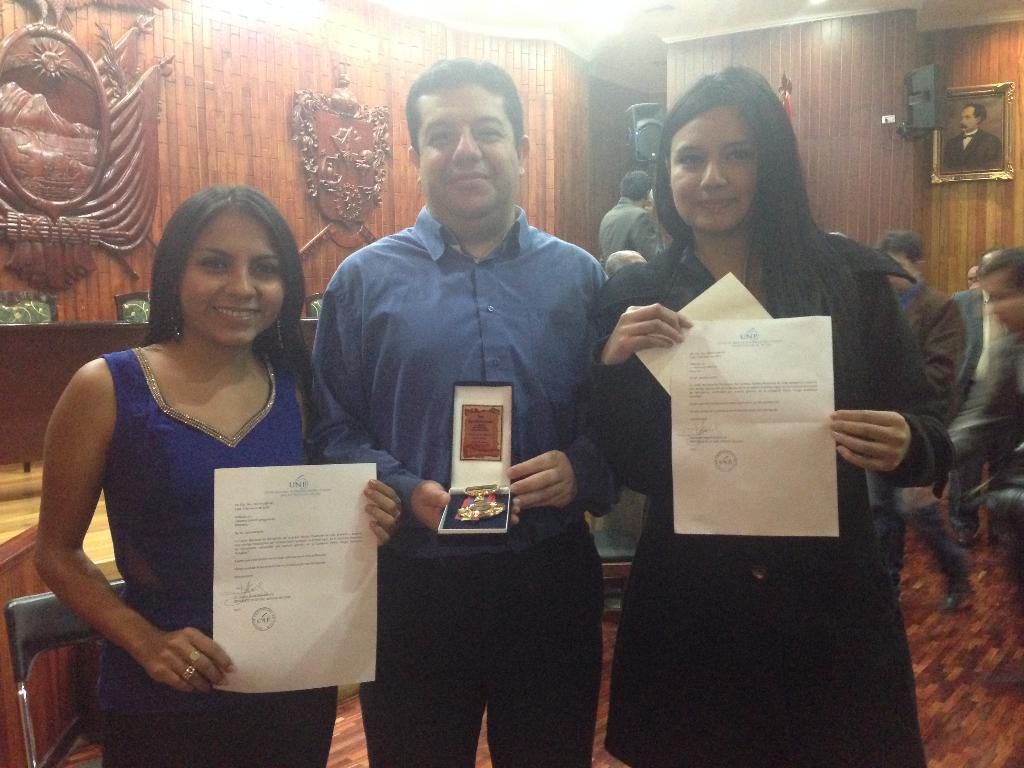Could you give a brief overview of what you see in this image? In the image there are two ladies and one man is standing and holding papers and a box in their hands. Behind them on the right side there are few people standing. And in the background there is a wall with sculptures, speakers and also there is a frame. 